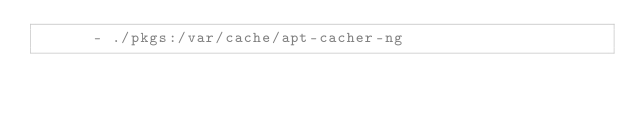<code> <loc_0><loc_0><loc_500><loc_500><_YAML_>      - ./pkgs:/var/cache/apt-cacher-ng

</code> 